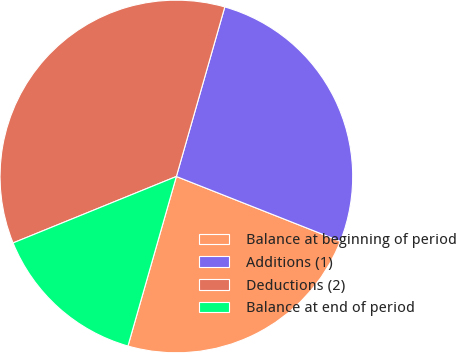Convert chart to OTSL. <chart><loc_0><loc_0><loc_500><loc_500><pie_chart><fcel>Balance at beginning of period<fcel>Additions (1)<fcel>Deductions (2)<fcel>Balance at end of period<nl><fcel>23.44%<fcel>26.56%<fcel>35.58%<fcel>14.42%<nl></chart> 